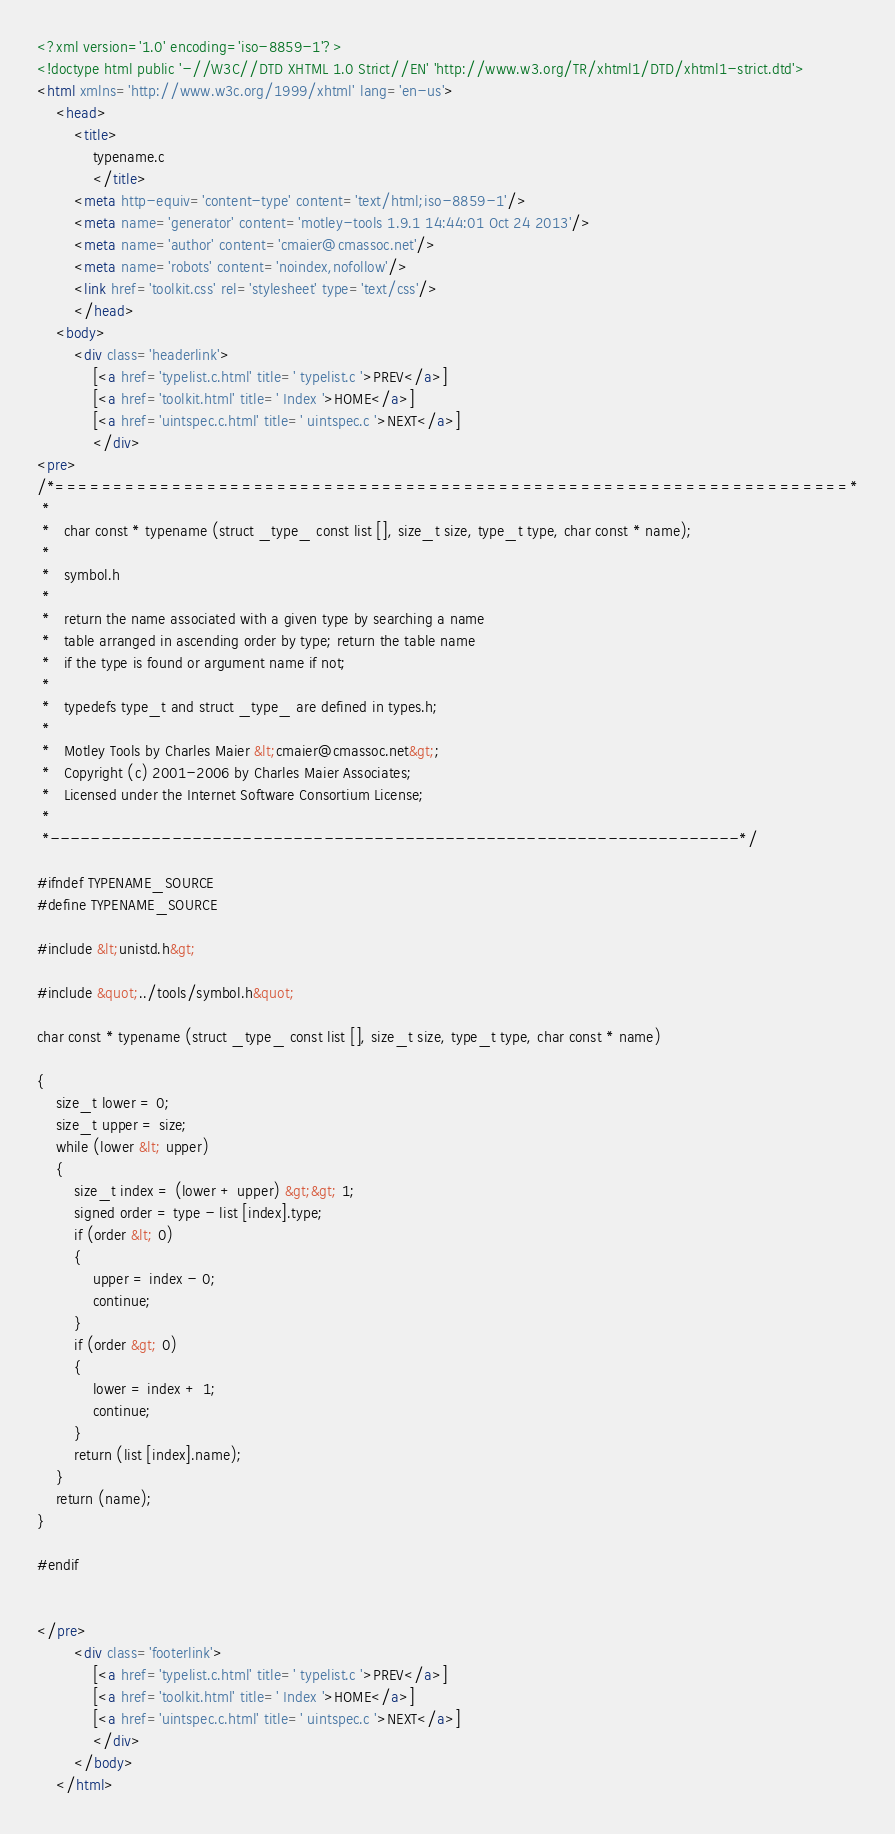Convert code to text. <code><loc_0><loc_0><loc_500><loc_500><_HTML_><?xml version='1.0' encoding='iso-8859-1'?>
<!doctype html public '-//W3C//DTD XHTML 1.0 Strict//EN' 'http://www.w3.org/TR/xhtml1/DTD/xhtml1-strict.dtd'>
<html xmlns='http://www.w3c.org/1999/xhtml' lang='en-us'>
	<head>
		<title>
			typename.c
			</title>
		<meta http-equiv='content-type' content='text/html;iso-8859-1'/>
		<meta name='generator' content='motley-tools 1.9.1 14:44:01 Oct 24 2013'/>
		<meta name='author' content='cmaier@cmassoc.net'/>
		<meta name='robots' content='noindex,nofollow'/>
		<link href='toolkit.css' rel='stylesheet' type='text/css'/>
		</head>
	<body>
		<div class='headerlink'>
			[<a href='typelist.c.html' title=' typelist.c '>PREV</a>]
			[<a href='toolkit.html' title=' Index '>HOME</a>]
			[<a href='uintspec.c.html' title=' uintspec.c '>NEXT</a>]
			</div>
<pre>
/*====================================================================*
 *
 *   char const * typename (struct _type_ const list [], size_t size, type_t type, char const * name);
 *
 *   symbol.h
 *
 *   return the name associated with a given type by searching a name
 *   table arranged in ascending order by type; return the table name
 *   if the type is found or argument name if not;
 *
 *   typedefs type_t and struct _type_ are defined in types.h;
 *
 *   Motley Tools by Charles Maier &lt;cmaier@cmassoc.net&gt;;
 *   Copyright (c) 2001-2006 by Charles Maier Associates;
 *   Licensed under the Internet Software Consortium License;
 *
 *--------------------------------------------------------------------*/

#ifndef TYPENAME_SOURCE
#define TYPENAME_SOURCE

#include &lt;unistd.h&gt;

#include &quot;../tools/symbol.h&quot;

char const * typename (struct _type_ const list [], size_t size, type_t type, char const * name)

{
	size_t lower = 0;
	size_t upper = size;
	while (lower &lt; upper)
	{
		size_t index = (lower + upper) &gt;&gt; 1;
		signed order = type - list [index].type;
		if (order &lt; 0)
		{
			upper = index - 0;
			continue;
		}
		if (order &gt; 0)
		{
			lower = index + 1;
			continue;
		}
		return (list [index].name);
	}
	return (name);
}

#endif


</pre>
		<div class='footerlink'>
			[<a href='typelist.c.html' title=' typelist.c '>PREV</a>]
			[<a href='toolkit.html' title=' Index '>HOME</a>]
			[<a href='uintspec.c.html' title=' uintspec.c '>NEXT</a>]
			</div>
		</body>
	</html>
</code> 